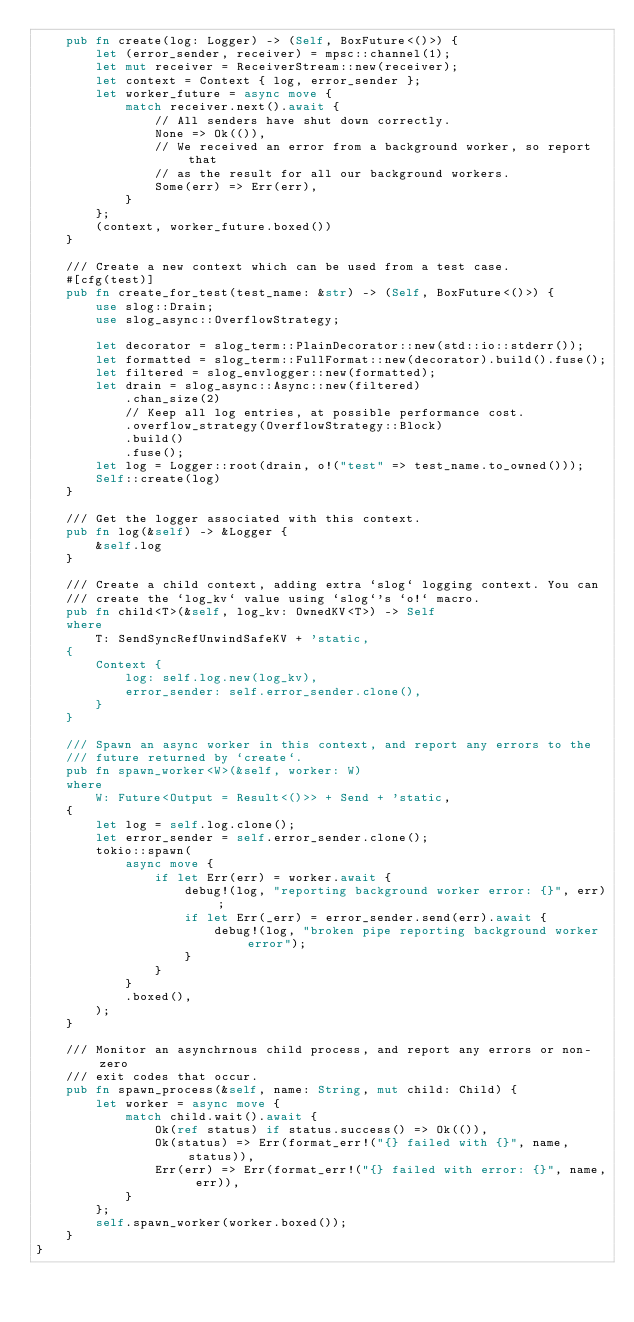Convert code to text. <code><loc_0><loc_0><loc_500><loc_500><_Rust_>    pub fn create(log: Logger) -> (Self, BoxFuture<()>) {
        let (error_sender, receiver) = mpsc::channel(1);
        let mut receiver = ReceiverStream::new(receiver);
        let context = Context { log, error_sender };
        let worker_future = async move {
            match receiver.next().await {
                // All senders have shut down correctly.
                None => Ok(()),
                // We received an error from a background worker, so report that
                // as the result for all our background workers.
                Some(err) => Err(err),
            }
        };
        (context, worker_future.boxed())
    }

    /// Create a new context which can be used from a test case.
    #[cfg(test)]
    pub fn create_for_test(test_name: &str) -> (Self, BoxFuture<()>) {
        use slog::Drain;
        use slog_async::OverflowStrategy;

        let decorator = slog_term::PlainDecorator::new(std::io::stderr());
        let formatted = slog_term::FullFormat::new(decorator).build().fuse();
        let filtered = slog_envlogger::new(formatted);
        let drain = slog_async::Async::new(filtered)
            .chan_size(2)
            // Keep all log entries, at possible performance cost.
            .overflow_strategy(OverflowStrategy::Block)
            .build()
            .fuse();
        let log = Logger::root(drain, o!("test" => test_name.to_owned()));
        Self::create(log)
    }

    /// Get the logger associated with this context.
    pub fn log(&self) -> &Logger {
        &self.log
    }

    /// Create a child context, adding extra `slog` logging context. You can
    /// create the `log_kv` value using `slog`'s `o!` macro.
    pub fn child<T>(&self, log_kv: OwnedKV<T>) -> Self
    where
        T: SendSyncRefUnwindSafeKV + 'static,
    {
        Context {
            log: self.log.new(log_kv),
            error_sender: self.error_sender.clone(),
        }
    }

    /// Spawn an async worker in this context, and report any errors to the
    /// future returned by `create`.
    pub fn spawn_worker<W>(&self, worker: W)
    where
        W: Future<Output = Result<()>> + Send + 'static,
    {
        let log = self.log.clone();
        let error_sender = self.error_sender.clone();
        tokio::spawn(
            async move {
                if let Err(err) = worker.await {
                    debug!(log, "reporting background worker error: {}", err);
                    if let Err(_err) = error_sender.send(err).await {
                        debug!(log, "broken pipe reporting background worker error");
                    }
                }
            }
            .boxed(),
        );
    }

    /// Monitor an asynchrnous child process, and report any errors or non-zero
    /// exit codes that occur.
    pub fn spawn_process(&self, name: String, mut child: Child) {
        let worker = async move {
            match child.wait().await {
                Ok(ref status) if status.success() => Ok(()),
                Ok(status) => Err(format_err!("{} failed with {}", name, status)),
                Err(err) => Err(format_err!("{} failed with error: {}", name, err)),
            }
        };
        self.spawn_worker(worker.boxed());
    }
}
</code> 